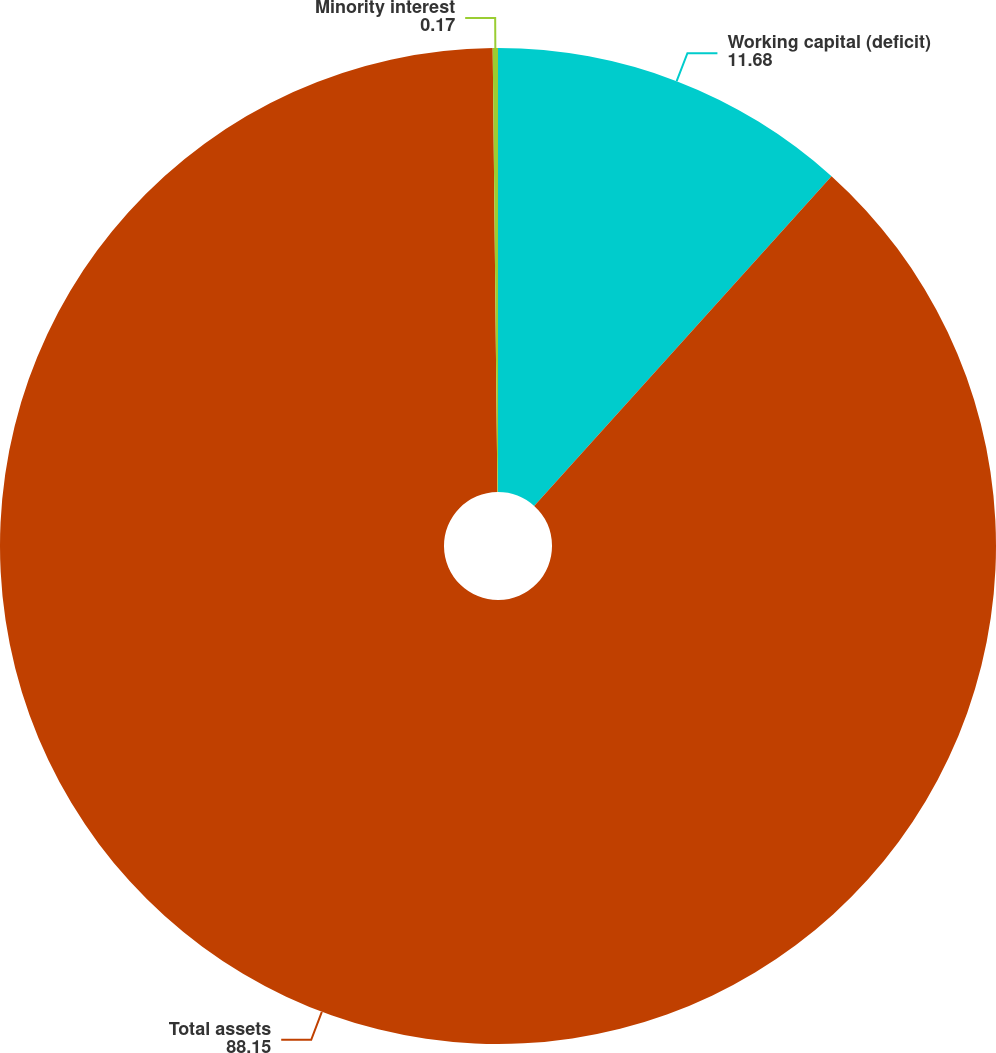Convert chart. <chart><loc_0><loc_0><loc_500><loc_500><pie_chart><fcel>Working capital (deficit)<fcel>Total assets<fcel>Minority interest<nl><fcel>11.68%<fcel>88.15%<fcel>0.17%<nl></chart> 